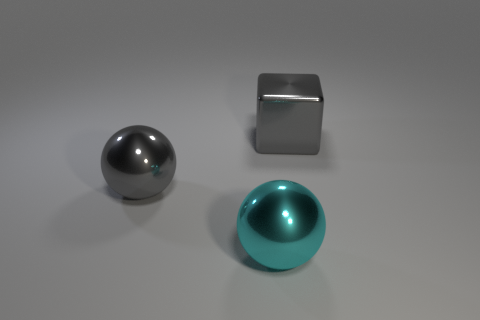Add 1 large cyan objects. How many objects exist? 4 Subtract all cubes. How many objects are left? 2 Subtract all gray shiny balls. Subtract all small yellow matte things. How many objects are left? 2 Add 2 spheres. How many spheres are left? 4 Add 2 tiny brown spheres. How many tiny brown spheres exist? 2 Subtract 0 yellow cylinders. How many objects are left? 3 